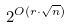Convert formula to latex. <formula><loc_0><loc_0><loc_500><loc_500>2 ^ { O ( r \cdot \sqrt { n } ) }</formula> 